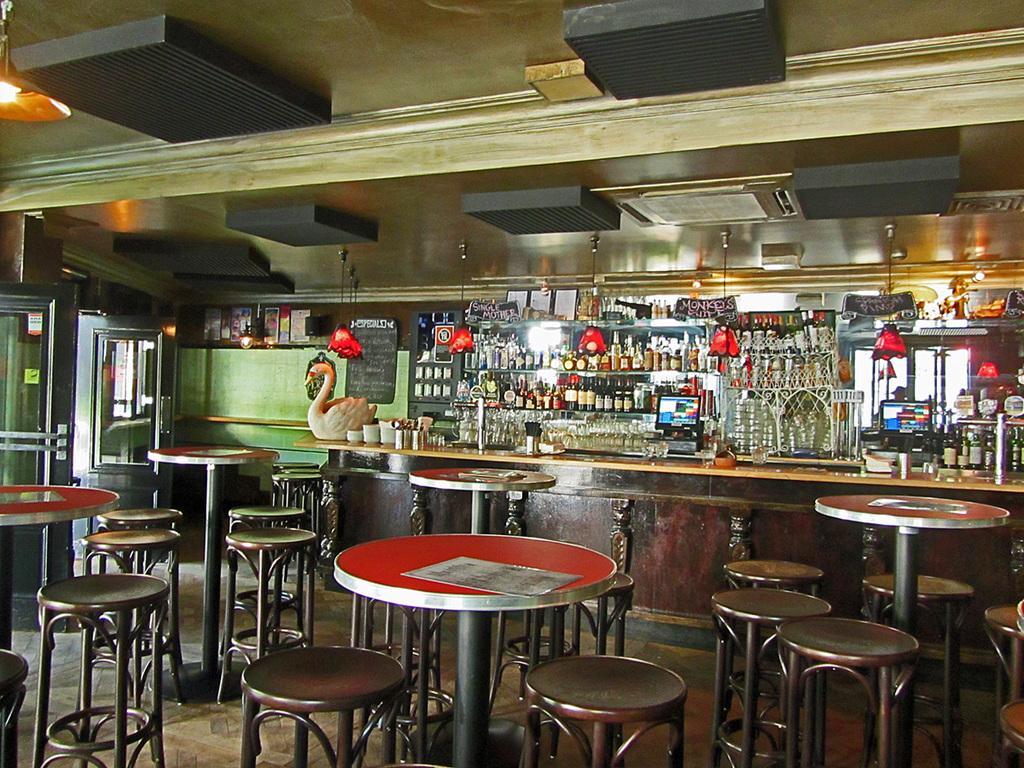Could you give a brief overview of what you see in this image? In this picture I can see the inside view of a building and in the front of the picture I can see stools and the tables. In the background I can see the counter top on which there are many things and on the racks I see number of bottles and other things and I see the ceiling and I can see the light on the top left of this image. 